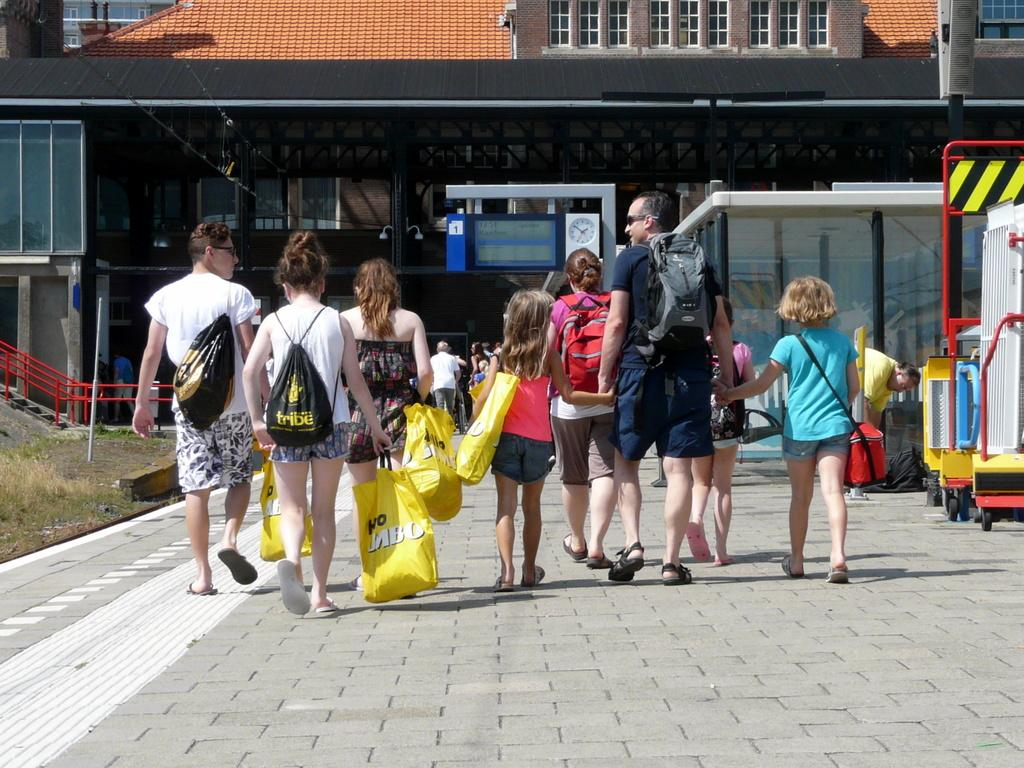What is happening on the left side of the image? There is a man walking on the left side of the image. What is the man wearing? The man is wearing a white t-shirt. Who is accompanying the man in the image? There are two girls walking beside the man. How are the girls described in the image? The girls are described as beautiful. What type of structure can be seen in the image? There appears to be a building in the image. What type of farm equipment can be seen in the image? There is no farm equipment present in the image. Is there a fight happening between the man and the girls in the image? No, there is no fight depicted in the image; the man and girls are walking together. What is the man using to cut the girls' hair in the image? There are no scissors or hair-cutting activity shown in the image. 